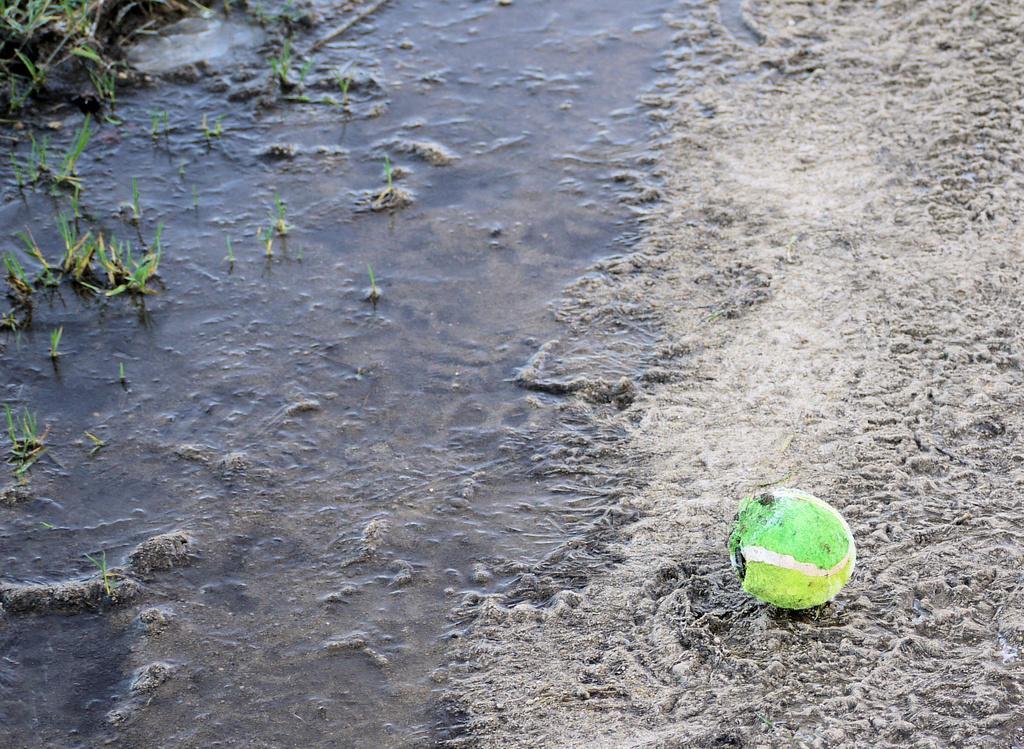Can you describe this image briefly? In the picture I can see a green color object on the ground. In the background I can see the water and the grass. 